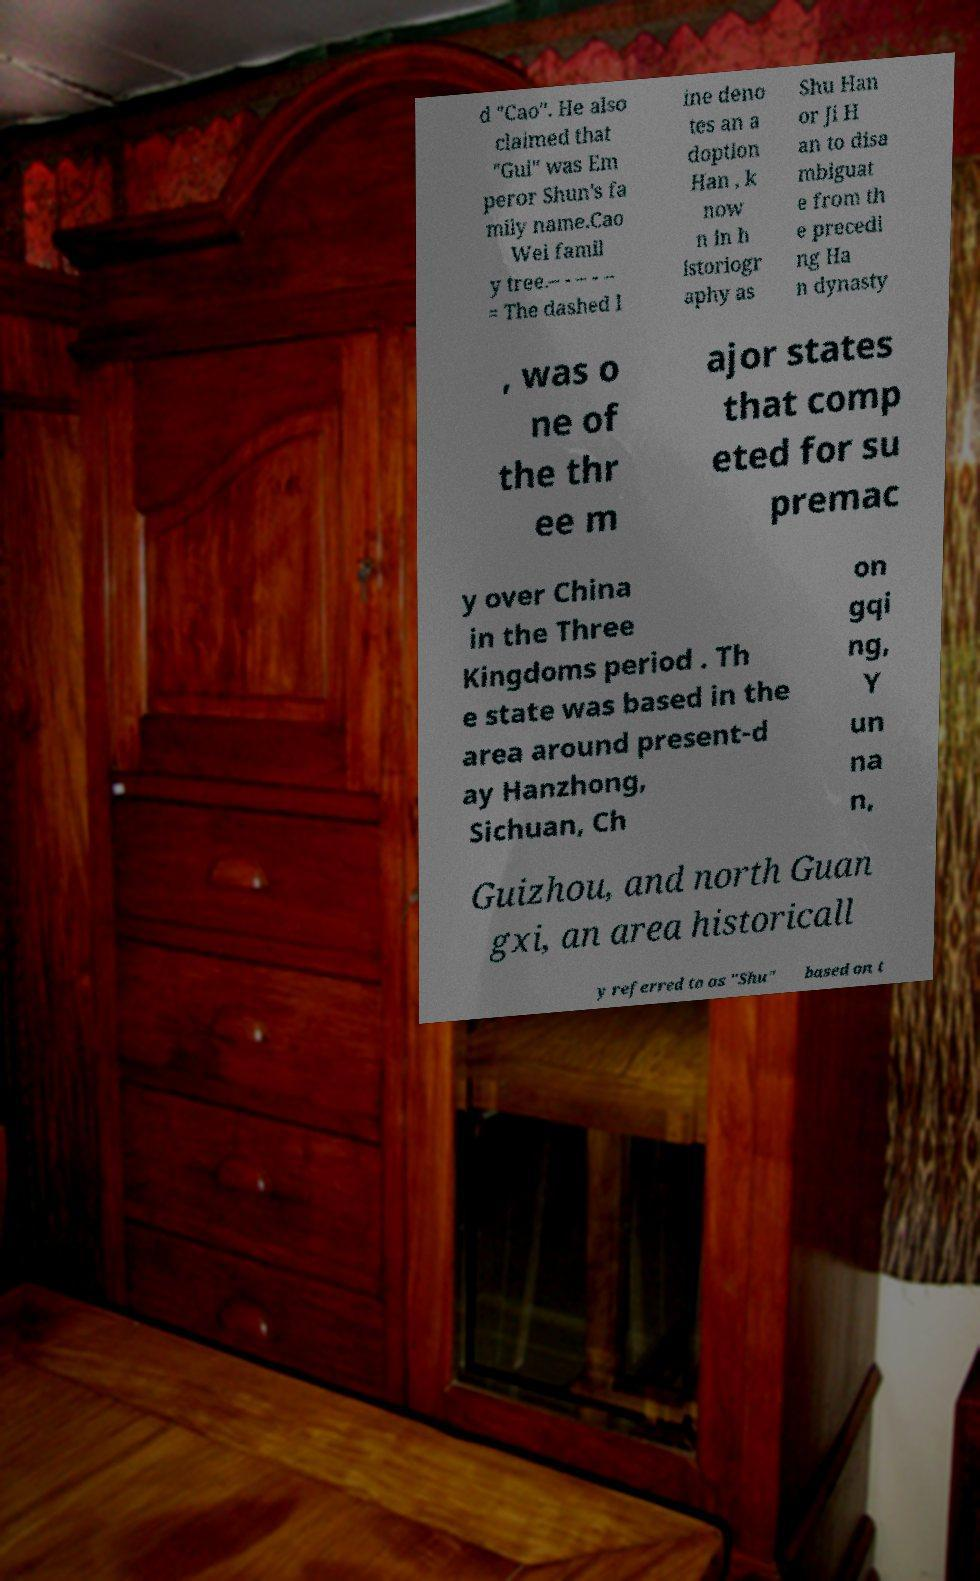What messages or text are displayed in this image? I need them in a readable, typed format. d "Cao". He also claimed that "Gui" was Em peror Shun's fa mily name.Cao Wei famil y tree.– - – - – = The dashed l ine deno tes an a doption Han , k now n in h istoriogr aphy as Shu Han or Ji H an to disa mbiguat e from th e precedi ng Ha n dynasty , was o ne of the thr ee m ajor states that comp eted for su premac y over China in the Three Kingdoms period . Th e state was based in the area around present-d ay Hanzhong, Sichuan, Ch on gqi ng, Y un na n, Guizhou, and north Guan gxi, an area historicall y referred to as "Shu" based on t 